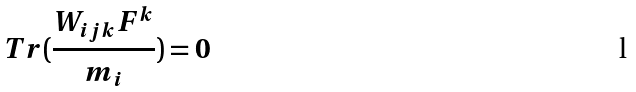Convert formula to latex. <formula><loc_0><loc_0><loc_500><loc_500>T r ( \frac { W _ { i j k } F ^ { k } } { m _ { i } } ) = 0</formula> 